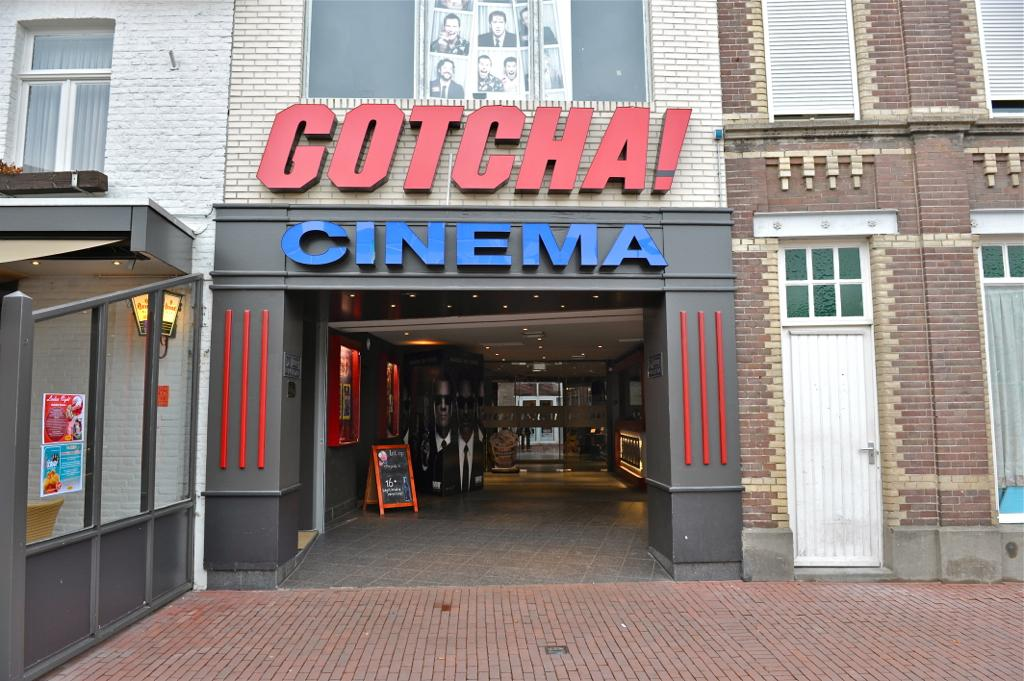What type of structure is present in the image? There is a building in the image. What feature can be observed on the building's exterior? The building has glass windows. Is there a way to enter the building? Yes, the building has a door. What is attached to the glass windows? Boards and papers are attached to the glass window. Can you describe the fear that the building is experiencing in the image? Buildings do not experience fear, as they are inanimate objects. 